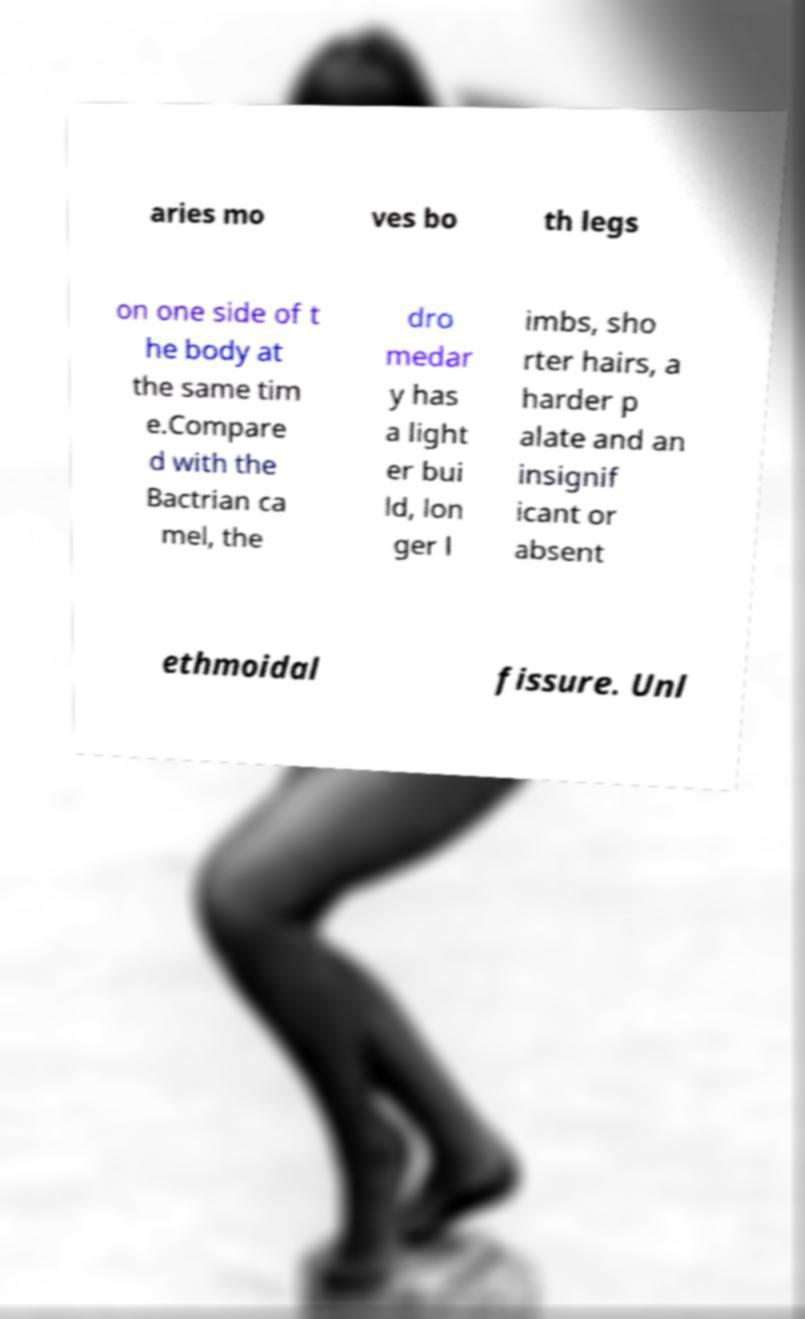I need the written content from this picture converted into text. Can you do that? aries mo ves bo th legs on one side of t he body at the same tim e.Compare d with the Bactrian ca mel, the dro medar y has a light er bui ld, lon ger l imbs, sho rter hairs, a harder p alate and an insignif icant or absent ethmoidal fissure. Unl 